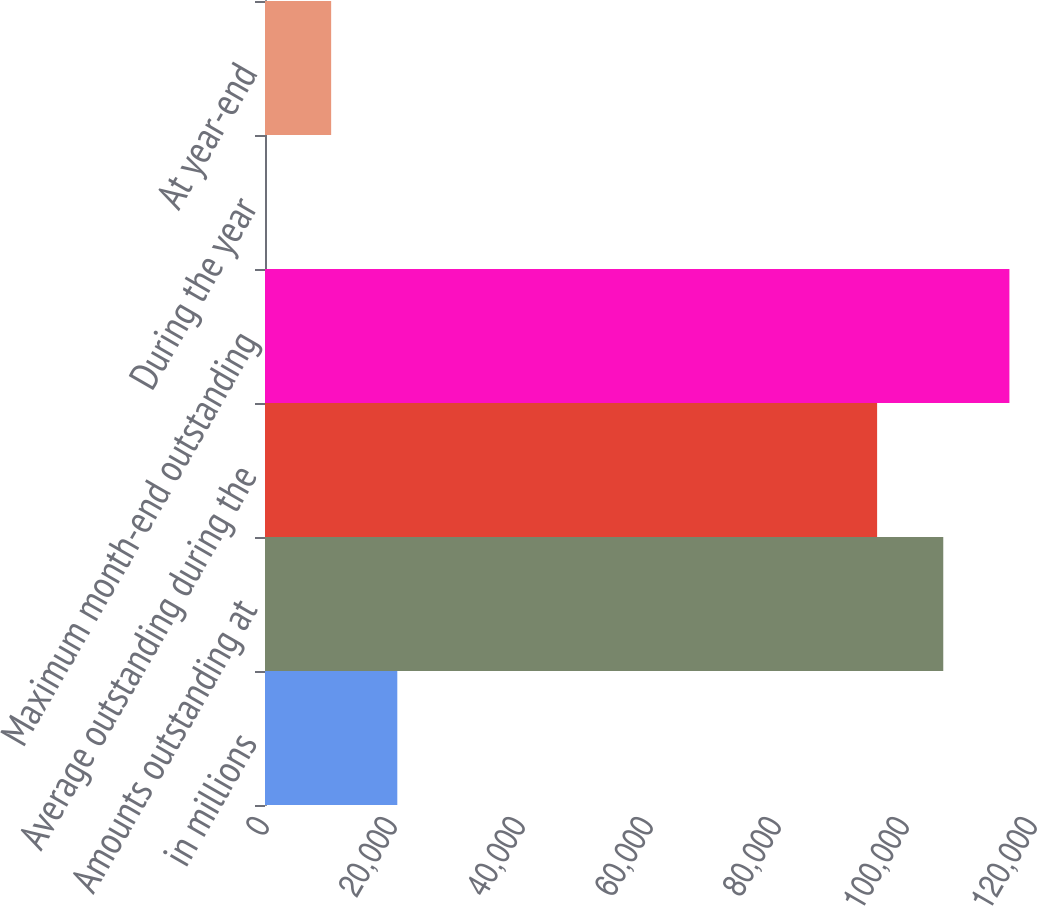Convert chart to OTSL. <chart><loc_0><loc_0><loc_500><loc_500><bar_chart><fcel>in millions<fcel>Amounts outstanding at<fcel>Average outstanding during the<fcel>Maximum month-end outstanding<fcel>During the year<fcel>At year-end<nl><fcel>20672.5<fcel>105979<fcel>95643<fcel>116315<fcel>0.9<fcel>10336.7<nl></chart> 